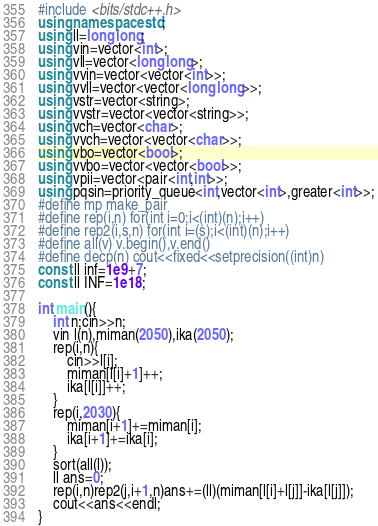<code> <loc_0><loc_0><loc_500><loc_500><_C++_>#include <bits/stdc++.h>
using namespace std;
using ll=long long;
using vin=vector<int>;
using vll=vector<long long>;
using vvin=vector<vector<int>>;
using vvll=vector<vector<long long>>;
using vstr=vector<string>;
using vvstr=vector<vector<string>>;
using vch=vector<char>;
using vvch=vector<vector<char>>;
using vbo=vector<bool>;
using vvbo=vector<vector<bool>>;
using vpii=vector<pair<int,int>>;
using pqsin=priority_queue<int,vector<int>,greater<int>>;
#define mp make_pair
#define rep(i,n) for(int i=0;i<(int)(n);i++)
#define rep2(i,s,n) for(int i=(s);i<(int)(n);i++)
#define all(v) v.begin(),v.end()
#define decp(n) cout<<fixed<<setprecision((int)n)
const ll inf=1e9+7;
const ll INF=1e18;

int main(){
    int n;cin>>n;
    vin l(n),miman(2050),ika(2050);
    rep(i,n){
        cin>>l[i];
        miman[l[i]+1]++;
        ika[l[i]]++;
    }
    rep(i,2030){
        miman[i+1]+=miman[i];
        ika[i+1]+=ika[i];
    }
    sort(all(l));
    ll ans=0;
    rep(i,n)rep2(j,i+1,n)ans+=(ll)(miman[l[i]+l[j]]-ika[l[j]]);
    cout<<ans<<endl;
}</code> 